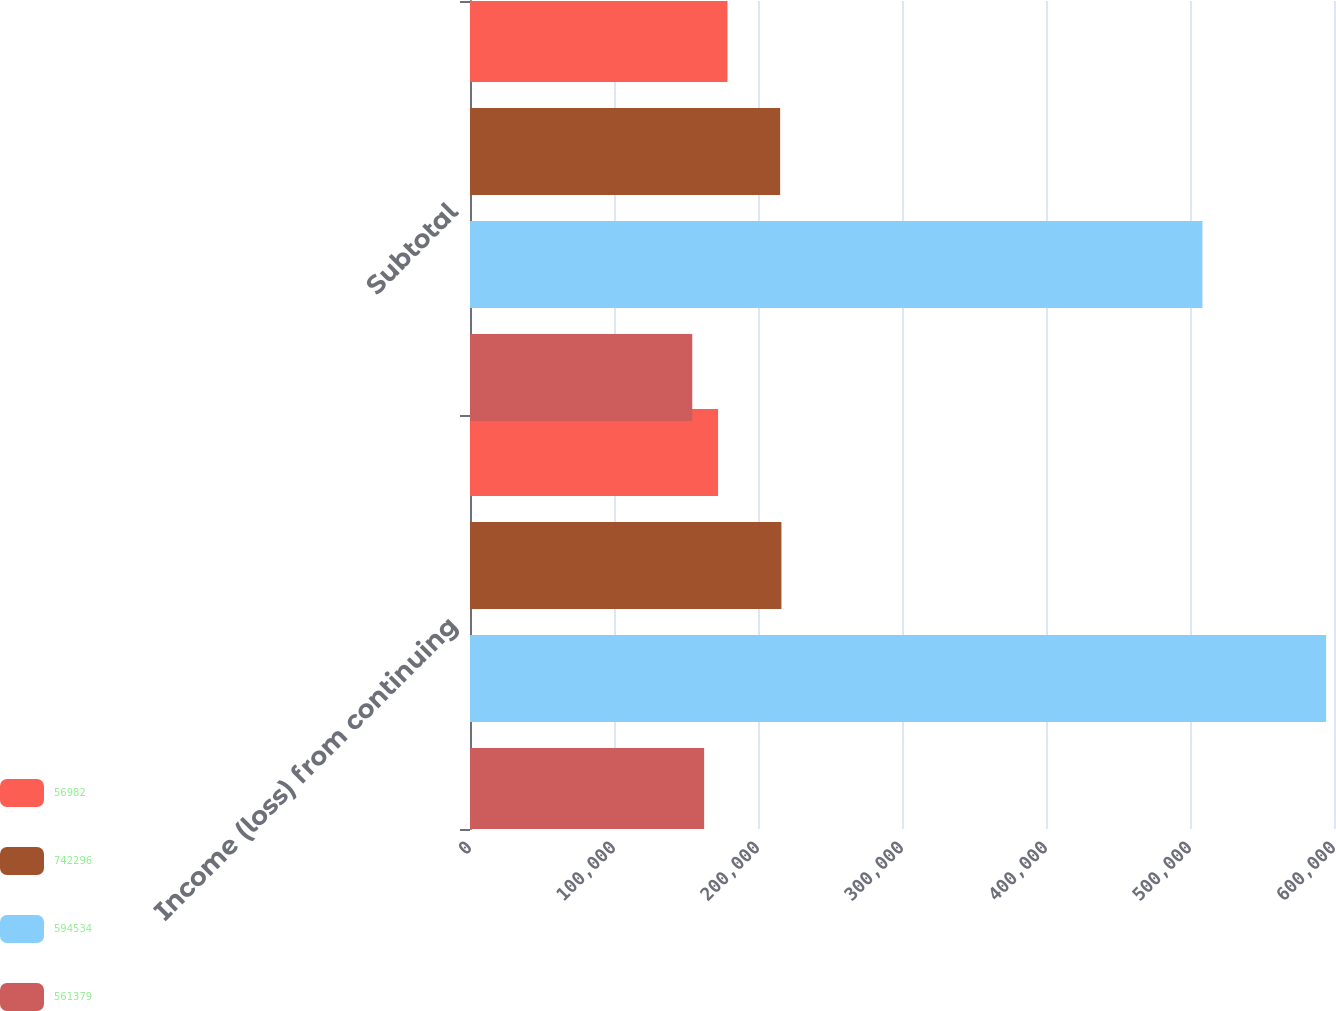Convert chart. <chart><loc_0><loc_0><loc_500><loc_500><stacked_bar_chart><ecel><fcel>Income (loss) from continuing<fcel>Subtotal<nl><fcel>56982<fcel>172270<fcel>178798<nl><fcel>742296<fcel>216257<fcel>215377<nl><fcel>594534<fcel>594534<fcel>508616<nl><fcel>561379<fcel>162589<fcel>154355<nl></chart> 